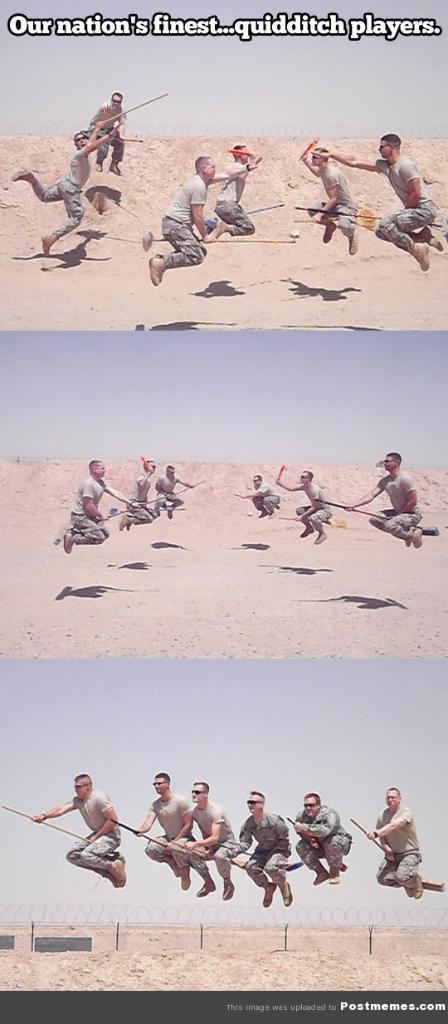<image>
Relay a brief, clear account of the picture shown. Military men posing as if they are playing quidditch. 